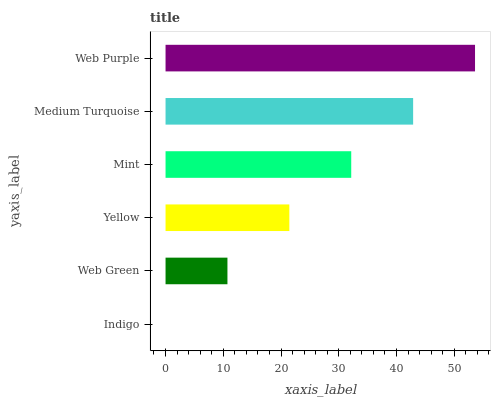Is Indigo the minimum?
Answer yes or no. Yes. Is Web Purple the maximum?
Answer yes or no. Yes. Is Web Green the minimum?
Answer yes or no. No. Is Web Green the maximum?
Answer yes or no. No. Is Web Green greater than Indigo?
Answer yes or no. Yes. Is Indigo less than Web Green?
Answer yes or no. Yes. Is Indigo greater than Web Green?
Answer yes or no. No. Is Web Green less than Indigo?
Answer yes or no. No. Is Mint the high median?
Answer yes or no. Yes. Is Yellow the low median?
Answer yes or no. Yes. Is Web Purple the high median?
Answer yes or no. No. Is Web Purple the low median?
Answer yes or no. No. 